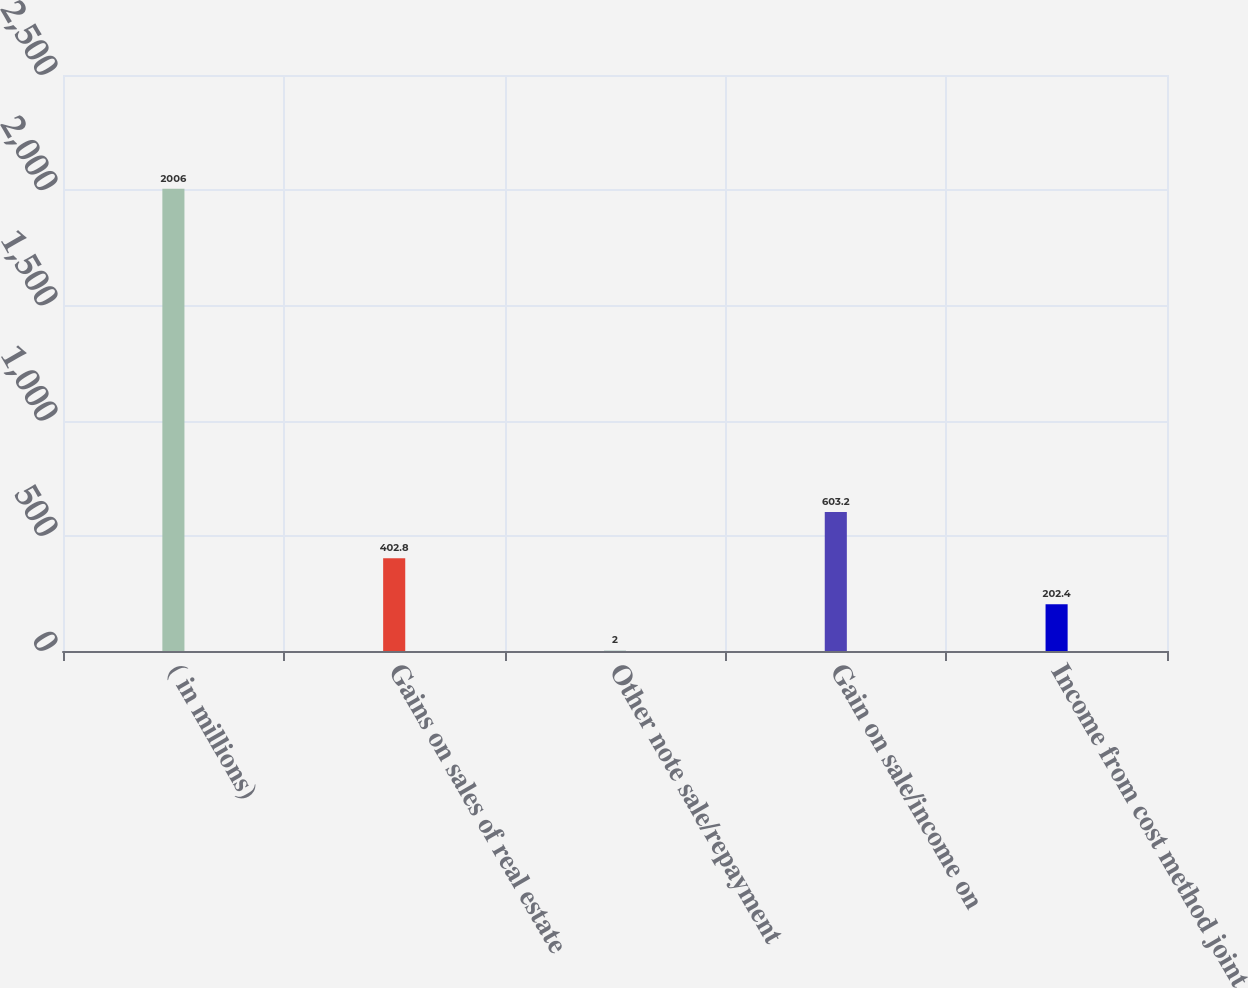Convert chart to OTSL. <chart><loc_0><loc_0><loc_500><loc_500><bar_chart><fcel>( in millions)<fcel>Gains on sales of real estate<fcel>Other note sale/repayment<fcel>Gain on sale/income on<fcel>Income from cost method joint<nl><fcel>2006<fcel>402.8<fcel>2<fcel>603.2<fcel>202.4<nl></chart> 